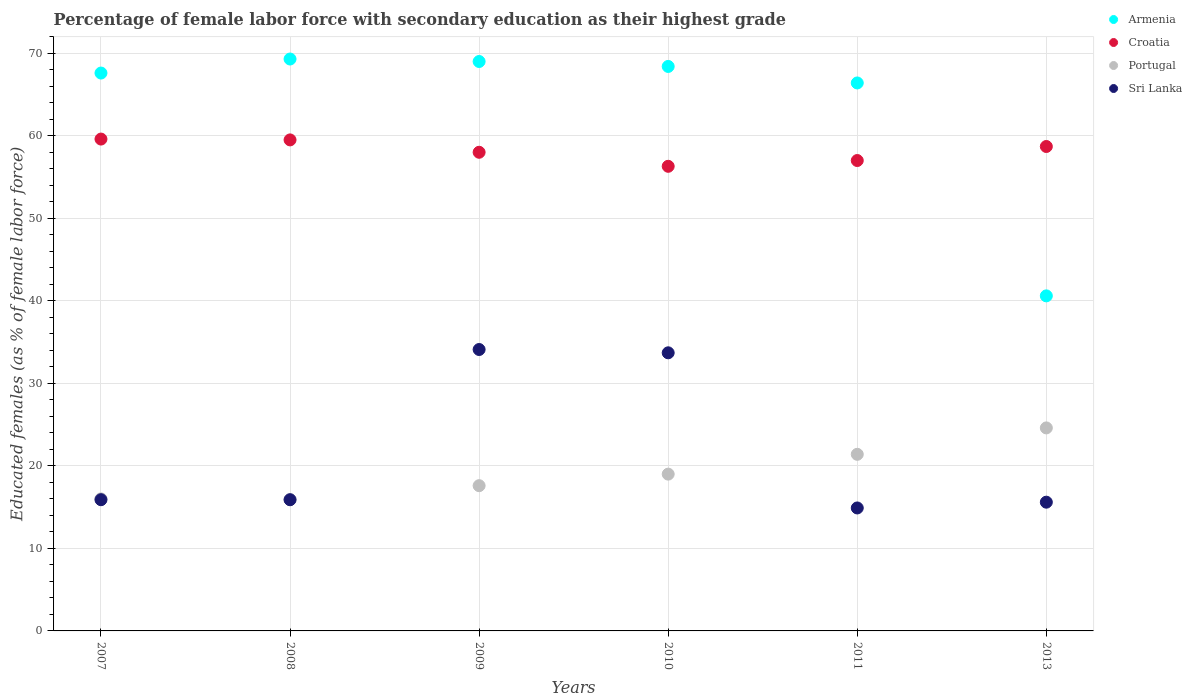How many different coloured dotlines are there?
Make the answer very short. 4. Across all years, what is the maximum percentage of female labor force with secondary education in Armenia?
Keep it short and to the point. 69.3. Across all years, what is the minimum percentage of female labor force with secondary education in Portugal?
Your answer should be compact. 15.9. In which year was the percentage of female labor force with secondary education in Croatia maximum?
Give a very brief answer. 2007. What is the total percentage of female labor force with secondary education in Sri Lanka in the graph?
Offer a very short reply. 130.1. What is the difference between the percentage of female labor force with secondary education in Sri Lanka in 2008 and that in 2013?
Keep it short and to the point. 0.3. What is the difference between the percentage of female labor force with secondary education in Armenia in 2007 and the percentage of female labor force with secondary education in Portugal in 2009?
Your answer should be very brief. 50. What is the average percentage of female labor force with secondary education in Croatia per year?
Your response must be concise. 58.18. In the year 2009, what is the difference between the percentage of female labor force with secondary education in Croatia and percentage of female labor force with secondary education in Sri Lanka?
Make the answer very short. 23.9. What is the ratio of the percentage of female labor force with secondary education in Croatia in 2009 to that in 2011?
Offer a terse response. 1.02. What is the difference between the highest and the second highest percentage of female labor force with secondary education in Sri Lanka?
Offer a terse response. 0.4. What is the difference between the highest and the lowest percentage of female labor force with secondary education in Armenia?
Provide a succinct answer. 28.7. Is it the case that in every year, the sum of the percentage of female labor force with secondary education in Sri Lanka and percentage of female labor force with secondary education in Croatia  is greater than the sum of percentage of female labor force with secondary education in Portugal and percentage of female labor force with secondary education in Armenia?
Give a very brief answer. Yes. Is it the case that in every year, the sum of the percentage of female labor force with secondary education in Croatia and percentage of female labor force with secondary education in Sri Lanka  is greater than the percentage of female labor force with secondary education in Portugal?
Ensure brevity in your answer.  Yes. Does the percentage of female labor force with secondary education in Sri Lanka monotonically increase over the years?
Provide a short and direct response. No. Is the percentage of female labor force with secondary education in Portugal strictly greater than the percentage of female labor force with secondary education in Armenia over the years?
Your answer should be compact. No. What is the difference between two consecutive major ticks on the Y-axis?
Give a very brief answer. 10. Are the values on the major ticks of Y-axis written in scientific E-notation?
Ensure brevity in your answer.  No. Does the graph contain grids?
Offer a very short reply. Yes. What is the title of the graph?
Your response must be concise. Percentage of female labor force with secondary education as their highest grade. Does "American Samoa" appear as one of the legend labels in the graph?
Provide a short and direct response. No. What is the label or title of the X-axis?
Give a very brief answer. Years. What is the label or title of the Y-axis?
Your answer should be very brief. Educated females (as % of female labor force). What is the Educated females (as % of female labor force) in Armenia in 2007?
Provide a succinct answer. 67.6. What is the Educated females (as % of female labor force) of Croatia in 2007?
Provide a succinct answer. 59.6. What is the Educated females (as % of female labor force) in Sri Lanka in 2007?
Give a very brief answer. 15.9. What is the Educated females (as % of female labor force) in Armenia in 2008?
Your response must be concise. 69.3. What is the Educated females (as % of female labor force) of Croatia in 2008?
Your response must be concise. 59.5. What is the Educated females (as % of female labor force) in Portugal in 2008?
Your answer should be compact. 15.9. What is the Educated females (as % of female labor force) of Sri Lanka in 2008?
Provide a short and direct response. 15.9. What is the Educated females (as % of female labor force) in Croatia in 2009?
Offer a terse response. 58. What is the Educated females (as % of female labor force) in Portugal in 2009?
Offer a very short reply. 17.6. What is the Educated females (as % of female labor force) in Sri Lanka in 2009?
Make the answer very short. 34.1. What is the Educated females (as % of female labor force) in Armenia in 2010?
Your answer should be very brief. 68.4. What is the Educated females (as % of female labor force) in Croatia in 2010?
Make the answer very short. 56.3. What is the Educated females (as % of female labor force) in Portugal in 2010?
Make the answer very short. 19. What is the Educated females (as % of female labor force) in Sri Lanka in 2010?
Keep it short and to the point. 33.7. What is the Educated females (as % of female labor force) in Armenia in 2011?
Your answer should be compact. 66.4. What is the Educated females (as % of female labor force) of Portugal in 2011?
Provide a short and direct response. 21.4. What is the Educated females (as % of female labor force) of Sri Lanka in 2011?
Provide a short and direct response. 14.9. What is the Educated females (as % of female labor force) in Armenia in 2013?
Provide a short and direct response. 40.6. What is the Educated females (as % of female labor force) of Croatia in 2013?
Make the answer very short. 58.7. What is the Educated females (as % of female labor force) in Portugal in 2013?
Ensure brevity in your answer.  24.6. What is the Educated females (as % of female labor force) of Sri Lanka in 2013?
Provide a succinct answer. 15.6. Across all years, what is the maximum Educated females (as % of female labor force) of Armenia?
Provide a succinct answer. 69.3. Across all years, what is the maximum Educated females (as % of female labor force) in Croatia?
Your answer should be compact. 59.6. Across all years, what is the maximum Educated females (as % of female labor force) of Portugal?
Give a very brief answer. 24.6. Across all years, what is the maximum Educated females (as % of female labor force) of Sri Lanka?
Provide a short and direct response. 34.1. Across all years, what is the minimum Educated females (as % of female labor force) in Armenia?
Provide a short and direct response. 40.6. Across all years, what is the minimum Educated females (as % of female labor force) in Croatia?
Provide a succinct answer. 56.3. Across all years, what is the minimum Educated females (as % of female labor force) of Portugal?
Provide a short and direct response. 15.9. Across all years, what is the minimum Educated females (as % of female labor force) in Sri Lanka?
Offer a very short reply. 14.9. What is the total Educated females (as % of female labor force) of Armenia in the graph?
Offer a terse response. 381.3. What is the total Educated females (as % of female labor force) of Croatia in the graph?
Make the answer very short. 349.1. What is the total Educated females (as % of female labor force) of Portugal in the graph?
Provide a succinct answer. 114.5. What is the total Educated females (as % of female labor force) of Sri Lanka in the graph?
Your answer should be compact. 130.1. What is the difference between the Educated females (as % of female labor force) in Croatia in 2007 and that in 2008?
Give a very brief answer. 0.1. What is the difference between the Educated females (as % of female labor force) of Portugal in 2007 and that in 2008?
Make the answer very short. 0.1. What is the difference between the Educated females (as % of female labor force) in Armenia in 2007 and that in 2009?
Offer a very short reply. -1.4. What is the difference between the Educated females (as % of female labor force) in Croatia in 2007 and that in 2009?
Provide a short and direct response. 1.6. What is the difference between the Educated females (as % of female labor force) of Sri Lanka in 2007 and that in 2009?
Your answer should be compact. -18.2. What is the difference between the Educated females (as % of female labor force) of Croatia in 2007 and that in 2010?
Offer a terse response. 3.3. What is the difference between the Educated females (as % of female labor force) of Sri Lanka in 2007 and that in 2010?
Give a very brief answer. -17.8. What is the difference between the Educated females (as % of female labor force) of Armenia in 2007 and that in 2011?
Offer a terse response. 1.2. What is the difference between the Educated females (as % of female labor force) of Croatia in 2007 and that in 2011?
Your answer should be very brief. 2.6. What is the difference between the Educated females (as % of female labor force) of Portugal in 2007 and that in 2011?
Provide a short and direct response. -5.4. What is the difference between the Educated females (as % of female labor force) of Sri Lanka in 2007 and that in 2011?
Offer a very short reply. 1. What is the difference between the Educated females (as % of female labor force) in Croatia in 2007 and that in 2013?
Your response must be concise. 0.9. What is the difference between the Educated females (as % of female labor force) in Sri Lanka in 2007 and that in 2013?
Give a very brief answer. 0.3. What is the difference between the Educated females (as % of female labor force) in Armenia in 2008 and that in 2009?
Give a very brief answer. 0.3. What is the difference between the Educated females (as % of female labor force) in Portugal in 2008 and that in 2009?
Keep it short and to the point. -1.7. What is the difference between the Educated females (as % of female labor force) of Sri Lanka in 2008 and that in 2009?
Your response must be concise. -18.2. What is the difference between the Educated females (as % of female labor force) of Armenia in 2008 and that in 2010?
Offer a very short reply. 0.9. What is the difference between the Educated females (as % of female labor force) of Croatia in 2008 and that in 2010?
Your answer should be compact. 3.2. What is the difference between the Educated females (as % of female labor force) in Portugal in 2008 and that in 2010?
Ensure brevity in your answer.  -3.1. What is the difference between the Educated females (as % of female labor force) in Sri Lanka in 2008 and that in 2010?
Your answer should be compact. -17.8. What is the difference between the Educated females (as % of female labor force) of Portugal in 2008 and that in 2011?
Keep it short and to the point. -5.5. What is the difference between the Educated females (as % of female labor force) of Armenia in 2008 and that in 2013?
Provide a succinct answer. 28.7. What is the difference between the Educated females (as % of female labor force) in Croatia in 2008 and that in 2013?
Make the answer very short. 0.8. What is the difference between the Educated females (as % of female labor force) in Armenia in 2009 and that in 2010?
Your response must be concise. 0.6. What is the difference between the Educated females (as % of female labor force) in Sri Lanka in 2009 and that in 2010?
Your response must be concise. 0.4. What is the difference between the Educated females (as % of female labor force) in Croatia in 2009 and that in 2011?
Your answer should be compact. 1. What is the difference between the Educated females (as % of female labor force) in Portugal in 2009 and that in 2011?
Make the answer very short. -3.8. What is the difference between the Educated females (as % of female labor force) in Armenia in 2009 and that in 2013?
Provide a short and direct response. 28.4. What is the difference between the Educated females (as % of female labor force) of Portugal in 2009 and that in 2013?
Offer a very short reply. -7. What is the difference between the Educated females (as % of female labor force) of Armenia in 2010 and that in 2011?
Provide a short and direct response. 2. What is the difference between the Educated females (as % of female labor force) of Croatia in 2010 and that in 2011?
Make the answer very short. -0.7. What is the difference between the Educated females (as % of female labor force) in Portugal in 2010 and that in 2011?
Your answer should be compact. -2.4. What is the difference between the Educated females (as % of female labor force) of Sri Lanka in 2010 and that in 2011?
Your answer should be compact. 18.8. What is the difference between the Educated females (as % of female labor force) of Armenia in 2010 and that in 2013?
Provide a short and direct response. 27.8. What is the difference between the Educated females (as % of female labor force) in Croatia in 2010 and that in 2013?
Ensure brevity in your answer.  -2.4. What is the difference between the Educated females (as % of female labor force) of Armenia in 2011 and that in 2013?
Offer a terse response. 25.8. What is the difference between the Educated females (as % of female labor force) in Armenia in 2007 and the Educated females (as % of female labor force) in Croatia in 2008?
Your response must be concise. 8.1. What is the difference between the Educated females (as % of female labor force) of Armenia in 2007 and the Educated females (as % of female labor force) of Portugal in 2008?
Offer a very short reply. 51.7. What is the difference between the Educated females (as % of female labor force) of Armenia in 2007 and the Educated females (as % of female labor force) of Sri Lanka in 2008?
Your answer should be very brief. 51.7. What is the difference between the Educated females (as % of female labor force) in Croatia in 2007 and the Educated females (as % of female labor force) in Portugal in 2008?
Your answer should be very brief. 43.7. What is the difference between the Educated females (as % of female labor force) in Croatia in 2007 and the Educated females (as % of female labor force) in Sri Lanka in 2008?
Give a very brief answer. 43.7. What is the difference between the Educated females (as % of female labor force) in Portugal in 2007 and the Educated females (as % of female labor force) in Sri Lanka in 2008?
Offer a terse response. 0.1. What is the difference between the Educated females (as % of female labor force) in Armenia in 2007 and the Educated females (as % of female labor force) in Croatia in 2009?
Your answer should be compact. 9.6. What is the difference between the Educated females (as % of female labor force) in Armenia in 2007 and the Educated females (as % of female labor force) in Portugal in 2009?
Give a very brief answer. 50. What is the difference between the Educated females (as % of female labor force) in Armenia in 2007 and the Educated females (as % of female labor force) in Sri Lanka in 2009?
Give a very brief answer. 33.5. What is the difference between the Educated females (as % of female labor force) of Croatia in 2007 and the Educated females (as % of female labor force) of Sri Lanka in 2009?
Your answer should be very brief. 25.5. What is the difference between the Educated females (as % of female labor force) of Portugal in 2007 and the Educated females (as % of female labor force) of Sri Lanka in 2009?
Offer a terse response. -18.1. What is the difference between the Educated females (as % of female labor force) in Armenia in 2007 and the Educated females (as % of female labor force) in Croatia in 2010?
Give a very brief answer. 11.3. What is the difference between the Educated females (as % of female labor force) in Armenia in 2007 and the Educated females (as % of female labor force) in Portugal in 2010?
Your response must be concise. 48.6. What is the difference between the Educated females (as % of female labor force) of Armenia in 2007 and the Educated females (as % of female labor force) of Sri Lanka in 2010?
Ensure brevity in your answer.  33.9. What is the difference between the Educated females (as % of female labor force) in Croatia in 2007 and the Educated females (as % of female labor force) in Portugal in 2010?
Make the answer very short. 40.6. What is the difference between the Educated females (as % of female labor force) in Croatia in 2007 and the Educated females (as % of female labor force) in Sri Lanka in 2010?
Keep it short and to the point. 25.9. What is the difference between the Educated females (as % of female labor force) of Portugal in 2007 and the Educated females (as % of female labor force) of Sri Lanka in 2010?
Provide a succinct answer. -17.7. What is the difference between the Educated females (as % of female labor force) of Armenia in 2007 and the Educated females (as % of female labor force) of Croatia in 2011?
Offer a terse response. 10.6. What is the difference between the Educated females (as % of female labor force) of Armenia in 2007 and the Educated females (as % of female labor force) of Portugal in 2011?
Offer a terse response. 46.2. What is the difference between the Educated females (as % of female labor force) of Armenia in 2007 and the Educated females (as % of female labor force) of Sri Lanka in 2011?
Your response must be concise. 52.7. What is the difference between the Educated females (as % of female labor force) of Croatia in 2007 and the Educated females (as % of female labor force) of Portugal in 2011?
Your answer should be compact. 38.2. What is the difference between the Educated females (as % of female labor force) of Croatia in 2007 and the Educated females (as % of female labor force) of Sri Lanka in 2011?
Offer a very short reply. 44.7. What is the difference between the Educated females (as % of female labor force) of Armenia in 2007 and the Educated females (as % of female labor force) of Croatia in 2013?
Keep it short and to the point. 8.9. What is the difference between the Educated females (as % of female labor force) in Armenia in 2007 and the Educated females (as % of female labor force) in Sri Lanka in 2013?
Provide a short and direct response. 52. What is the difference between the Educated females (as % of female labor force) of Croatia in 2007 and the Educated females (as % of female labor force) of Portugal in 2013?
Your response must be concise. 35. What is the difference between the Educated females (as % of female labor force) of Portugal in 2007 and the Educated females (as % of female labor force) of Sri Lanka in 2013?
Offer a very short reply. 0.4. What is the difference between the Educated females (as % of female labor force) in Armenia in 2008 and the Educated females (as % of female labor force) in Portugal in 2009?
Give a very brief answer. 51.7. What is the difference between the Educated females (as % of female labor force) in Armenia in 2008 and the Educated females (as % of female labor force) in Sri Lanka in 2009?
Your answer should be very brief. 35.2. What is the difference between the Educated females (as % of female labor force) in Croatia in 2008 and the Educated females (as % of female labor force) in Portugal in 2009?
Offer a very short reply. 41.9. What is the difference between the Educated females (as % of female labor force) of Croatia in 2008 and the Educated females (as % of female labor force) of Sri Lanka in 2009?
Provide a succinct answer. 25.4. What is the difference between the Educated females (as % of female labor force) in Portugal in 2008 and the Educated females (as % of female labor force) in Sri Lanka in 2009?
Provide a short and direct response. -18.2. What is the difference between the Educated females (as % of female labor force) of Armenia in 2008 and the Educated females (as % of female labor force) of Croatia in 2010?
Offer a terse response. 13. What is the difference between the Educated females (as % of female labor force) in Armenia in 2008 and the Educated females (as % of female labor force) in Portugal in 2010?
Your response must be concise. 50.3. What is the difference between the Educated females (as % of female labor force) of Armenia in 2008 and the Educated females (as % of female labor force) of Sri Lanka in 2010?
Ensure brevity in your answer.  35.6. What is the difference between the Educated females (as % of female labor force) of Croatia in 2008 and the Educated females (as % of female labor force) of Portugal in 2010?
Give a very brief answer. 40.5. What is the difference between the Educated females (as % of female labor force) of Croatia in 2008 and the Educated females (as % of female labor force) of Sri Lanka in 2010?
Provide a short and direct response. 25.8. What is the difference between the Educated females (as % of female labor force) in Portugal in 2008 and the Educated females (as % of female labor force) in Sri Lanka in 2010?
Offer a very short reply. -17.8. What is the difference between the Educated females (as % of female labor force) of Armenia in 2008 and the Educated females (as % of female labor force) of Croatia in 2011?
Offer a very short reply. 12.3. What is the difference between the Educated females (as % of female labor force) in Armenia in 2008 and the Educated females (as % of female labor force) in Portugal in 2011?
Provide a succinct answer. 47.9. What is the difference between the Educated females (as % of female labor force) in Armenia in 2008 and the Educated females (as % of female labor force) in Sri Lanka in 2011?
Your answer should be compact. 54.4. What is the difference between the Educated females (as % of female labor force) of Croatia in 2008 and the Educated females (as % of female labor force) of Portugal in 2011?
Keep it short and to the point. 38.1. What is the difference between the Educated females (as % of female labor force) of Croatia in 2008 and the Educated females (as % of female labor force) of Sri Lanka in 2011?
Your response must be concise. 44.6. What is the difference between the Educated females (as % of female labor force) in Armenia in 2008 and the Educated females (as % of female labor force) in Portugal in 2013?
Your answer should be very brief. 44.7. What is the difference between the Educated females (as % of female labor force) in Armenia in 2008 and the Educated females (as % of female labor force) in Sri Lanka in 2013?
Offer a terse response. 53.7. What is the difference between the Educated females (as % of female labor force) in Croatia in 2008 and the Educated females (as % of female labor force) in Portugal in 2013?
Make the answer very short. 34.9. What is the difference between the Educated females (as % of female labor force) in Croatia in 2008 and the Educated females (as % of female labor force) in Sri Lanka in 2013?
Give a very brief answer. 43.9. What is the difference between the Educated females (as % of female labor force) of Armenia in 2009 and the Educated females (as % of female labor force) of Croatia in 2010?
Make the answer very short. 12.7. What is the difference between the Educated females (as % of female labor force) in Armenia in 2009 and the Educated females (as % of female labor force) in Portugal in 2010?
Provide a succinct answer. 50. What is the difference between the Educated females (as % of female labor force) of Armenia in 2009 and the Educated females (as % of female labor force) of Sri Lanka in 2010?
Ensure brevity in your answer.  35.3. What is the difference between the Educated females (as % of female labor force) in Croatia in 2009 and the Educated females (as % of female labor force) in Portugal in 2010?
Your answer should be compact. 39. What is the difference between the Educated females (as % of female labor force) in Croatia in 2009 and the Educated females (as % of female labor force) in Sri Lanka in 2010?
Offer a very short reply. 24.3. What is the difference between the Educated females (as % of female labor force) of Portugal in 2009 and the Educated females (as % of female labor force) of Sri Lanka in 2010?
Make the answer very short. -16.1. What is the difference between the Educated females (as % of female labor force) of Armenia in 2009 and the Educated females (as % of female labor force) of Croatia in 2011?
Your answer should be very brief. 12. What is the difference between the Educated females (as % of female labor force) of Armenia in 2009 and the Educated females (as % of female labor force) of Portugal in 2011?
Your answer should be very brief. 47.6. What is the difference between the Educated females (as % of female labor force) in Armenia in 2009 and the Educated females (as % of female labor force) in Sri Lanka in 2011?
Keep it short and to the point. 54.1. What is the difference between the Educated females (as % of female labor force) in Croatia in 2009 and the Educated females (as % of female labor force) in Portugal in 2011?
Your answer should be compact. 36.6. What is the difference between the Educated females (as % of female labor force) in Croatia in 2009 and the Educated females (as % of female labor force) in Sri Lanka in 2011?
Your answer should be very brief. 43.1. What is the difference between the Educated females (as % of female labor force) in Armenia in 2009 and the Educated females (as % of female labor force) in Portugal in 2013?
Your answer should be compact. 44.4. What is the difference between the Educated females (as % of female labor force) of Armenia in 2009 and the Educated females (as % of female labor force) of Sri Lanka in 2013?
Give a very brief answer. 53.4. What is the difference between the Educated females (as % of female labor force) in Croatia in 2009 and the Educated females (as % of female labor force) in Portugal in 2013?
Give a very brief answer. 33.4. What is the difference between the Educated females (as % of female labor force) of Croatia in 2009 and the Educated females (as % of female labor force) of Sri Lanka in 2013?
Provide a succinct answer. 42.4. What is the difference between the Educated females (as % of female labor force) in Armenia in 2010 and the Educated females (as % of female labor force) in Croatia in 2011?
Offer a very short reply. 11.4. What is the difference between the Educated females (as % of female labor force) in Armenia in 2010 and the Educated females (as % of female labor force) in Portugal in 2011?
Offer a terse response. 47. What is the difference between the Educated females (as % of female labor force) of Armenia in 2010 and the Educated females (as % of female labor force) of Sri Lanka in 2011?
Offer a very short reply. 53.5. What is the difference between the Educated females (as % of female labor force) of Croatia in 2010 and the Educated females (as % of female labor force) of Portugal in 2011?
Make the answer very short. 34.9. What is the difference between the Educated females (as % of female labor force) in Croatia in 2010 and the Educated females (as % of female labor force) in Sri Lanka in 2011?
Ensure brevity in your answer.  41.4. What is the difference between the Educated females (as % of female labor force) in Portugal in 2010 and the Educated females (as % of female labor force) in Sri Lanka in 2011?
Give a very brief answer. 4.1. What is the difference between the Educated females (as % of female labor force) of Armenia in 2010 and the Educated females (as % of female labor force) of Portugal in 2013?
Offer a terse response. 43.8. What is the difference between the Educated females (as % of female labor force) of Armenia in 2010 and the Educated females (as % of female labor force) of Sri Lanka in 2013?
Keep it short and to the point. 52.8. What is the difference between the Educated females (as % of female labor force) of Croatia in 2010 and the Educated females (as % of female labor force) of Portugal in 2013?
Your answer should be very brief. 31.7. What is the difference between the Educated females (as % of female labor force) of Croatia in 2010 and the Educated females (as % of female labor force) of Sri Lanka in 2013?
Offer a terse response. 40.7. What is the difference between the Educated females (as % of female labor force) in Armenia in 2011 and the Educated females (as % of female labor force) in Croatia in 2013?
Make the answer very short. 7.7. What is the difference between the Educated females (as % of female labor force) in Armenia in 2011 and the Educated females (as % of female labor force) in Portugal in 2013?
Offer a terse response. 41.8. What is the difference between the Educated females (as % of female labor force) in Armenia in 2011 and the Educated females (as % of female labor force) in Sri Lanka in 2013?
Ensure brevity in your answer.  50.8. What is the difference between the Educated females (as % of female labor force) in Croatia in 2011 and the Educated females (as % of female labor force) in Portugal in 2013?
Keep it short and to the point. 32.4. What is the difference between the Educated females (as % of female labor force) of Croatia in 2011 and the Educated females (as % of female labor force) of Sri Lanka in 2013?
Your answer should be very brief. 41.4. What is the difference between the Educated females (as % of female labor force) in Portugal in 2011 and the Educated females (as % of female labor force) in Sri Lanka in 2013?
Provide a short and direct response. 5.8. What is the average Educated females (as % of female labor force) of Armenia per year?
Your answer should be very brief. 63.55. What is the average Educated females (as % of female labor force) of Croatia per year?
Your response must be concise. 58.18. What is the average Educated females (as % of female labor force) of Portugal per year?
Provide a succinct answer. 19.08. What is the average Educated females (as % of female labor force) of Sri Lanka per year?
Give a very brief answer. 21.68. In the year 2007, what is the difference between the Educated females (as % of female labor force) of Armenia and Educated females (as % of female labor force) of Portugal?
Provide a short and direct response. 51.6. In the year 2007, what is the difference between the Educated females (as % of female labor force) in Armenia and Educated females (as % of female labor force) in Sri Lanka?
Your answer should be very brief. 51.7. In the year 2007, what is the difference between the Educated females (as % of female labor force) in Croatia and Educated females (as % of female labor force) in Portugal?
Keep it short and to the point. 43.6. In the year 2007, what is the difference between the Educated females (as % of female labor force) in Croatia and Educated females (as % of female labor force) in Sri Lanka?
Provide a succinct answer. 43.7. In the year 2007, what is the difference between the Educated females (as % of female labor force) of Portugal and Educated females (as % of female labor force) of Sri Lanka?
Provide a succinct answer. 0.1. In the year 2008, what is the difference between the Educated females (as % of female labor force) of Armenia and Educated females (as % of female labor force) of Portugal?
Keep it short and to the point. 53.4. In the year 2008, what is the difference between the Educated females (as % of female labor force) in Armenia and Educated females (as % of female labor force) in Sri Lanka?
Provide a short and direct response. 53.4. In the year 2008, what is the difference between the Educated females (as % of female labor force) in Croatia and Educated females (as % of female labor force) in Portugal?
Keep it short and to the point. 43.6. In the year 2008, what is the difference between the Educated females (as % of female labor force) of Croatia and Educated females (as % of female labor force) of Sri Lanka?
Make the answer very short. 43.6. In the year 2009, what is the difference between the Educated females (as % of female labor force) in Armenia and Educated females (as % of female labor force) in Portugal?
Offer a terse response. 51.4. In the year 2009, what is the difference between the Educated females (as % of female labor force) of Armenia and Educated females (as % of female labor force) of Sri Lanka?
Offer a terse response. 34.9. In the year 2009, what is the difference between the Educated females (as % of female labor force) of Croatia and Educated females (as % of female labor force) of Portugal?
Offer a terse response. 40.4. In the year 2009, what is the difference between the Educated females (as % of female labor force) in Croatia and Educated females (as % of female labor force) in Sri Lanka?
Offer a terse response. 23.9. In the year 2009, what is the difference between the Educated females (as % of female labor force) of Portugal and Educated females (as % of female labor force) of Sri Lanka?
Your answer should be compact. -16.5. In the year 2010, what is the difference between the Educated females (as % of female labor force) of Armenia and Educated females (as % of female labor force) of Portugal?
Provide a short and direct response. 49.4. In the year 2010, what is the difference between the Educated females (as % of female labor force) of Armenia and Educated females (as % of female labor force) of Sri Lanka?
Offer a very short reply. 34.7. In the year 2010, what is the difference between the Educated females (as % of female labor force) of Croatia and Educated females (as % of female labor force) of Portugal?
Provide a short and direct response. 37.3. In the year 2010, what is the difference between the Educated females (as % of female labor force) of Croatia and Educated females (as % of female labor force) of Sri Lanka?
Your answer should be compact. 22.6. In the year 2010, what is the difference between the Educated females (as % of female labor force) in Portugal and Educated females (as % of female labor force) in Sri Lanka?
Offer a terse response. -14.7. In the year 2011, what is the difference between the Educated females (as % of female labor force) in Armenia and Educated females (as % of female labor force) in Croatia?
Your answer should be very brief. 9.4. In the year 2011, what is the difference between the Educated females (as % of female labor force) in Armenia and Educated females (as % of female labor force) in Sri Lanka?
Keep it short and to the point. 51.5. In the year 2011, what is the difference between the Educated females (as % of female labor force) in Croatia and Educated females (as % of female labor force) in Portugal?
Offer a very short reply. 35.6. In the year 2011, what is the difference between the Educated females (as % of female labor force) in Croatia and Educated females (as % of female labor force) in Sri Lanka?
Offer a terse response. 42.1. In the year 2011, what is the difference between the Educated females (as % of female labor force) in Portugal and Educated females (as % of female labor force) in Sri Lanka?
Give a very brief answer. 6.5. In the year 2013, what is the difference between the Educated females (as % of female labor force) of Armenia and Educated females (as % of female labor force) of Croatia?
Keep it short and to the point. -18.1. In the year 2013, what is the difference between the Educated females (as % of female labor force) of Armenia and Educated females (as % of female labor force) of Portugal?
Offer a terse response. 16. In the year 2013, what is the difference between the Educated females (as % of female labor force) in Armenia and Educated females (as % of female labor force) in Sri Lanka?
Offer a terse response. 25. In the year 2013, what is the difference between the Educated females (as % of female labor force) in Croatia and Educated females (as % of female labor force) in Portugal?
Offer a very short reply. 34.1. In the year 2013, what is the difference between the Educated females (as % of female labor force) of Croatia and Educated females (as % of female labor force) of Sri Lanka?
Your answer should be very brief. 43.1. What is the ratio of the Educated females (as % of female labor force) of Armenia in 2007 to that in 2008?
Give a very brief answer. 0.98. What is the ratio of the Educated females (as % of female labor force) in Croatia in 2007 to that in 2008?
Offer a very short reply. 1. What is the ratio of the Educated females (as % of female labor force) in Portugal in 2007 to that in 2008?
Provide a succinct answer. 1.01. What is the ratio of the Educated females (as % of female labor force) in Armenia in 2007 to that in 2009?
Offer a very short reply. 0.98. What is the ratio of the Educated females (as % of female labor force) in Croatia in 2007 to that in 2009?
Your answer should be compact. 1.03. What is the ratio of the Educated females (as % of female labor force) in Portugal in 2007 to that in 2009?
Offer a terse response. 0.91. What is the ratio of the Educated females (as % of female labor force) of Sri Lanka in 2007 to that in 2009?
Provide a short and direct response. 0.47. What is the ratio of the Educated females (as % of female labor force) in Armenia in 2007 to that in 2010?
Provide a short and direct response. 0.99. What is the ratio of the Educated females (as % of female labor force) in Croatia in 2007 to that in 2010?
Your response must be concise. 1.06. What is the ratio of the Educated females (as % of female labor force) of Portugal in 2007 to that in 2010?
Offer a very short reply. 0.84. What is the ratio of the Educated females (as % of female labor force) of Sri Lanka in 2007 to that in 2010?
Ensure brevity in your answer.  0.47. What is the ratio of the Educated females (as % of female labor force) of Armenia in 2007 to that in 2011?
Keep it short and to the point. 1.02. What is the ratio of the Educated females (as % of female labor force) in Croatia in 2007 to that in 2011?
Provide a succinct answer. 1.05. What is the ratio of the Educated females (as % of female labor force) in Portugal in 2007 to that in 2011?
Offer a terse response. 0.75. What is the ratio of the Educated females (as % of female labor force) of Sri Lanka in 2007 to that in 2011?
Ensure brevity in your answer.  1.07. What is the ratio of the Educated females (as % of female labor force) in Armenia in 2007 to that in 2013?
Make the answer very short. 1.67. What is the ratio of the Educated females (as % of female labor force) of Croatia in 2007 to that in 2013?
Ensure brevity in your answer.  1.02. What is the ratio of the Educated females (as % of female labor force) of Portugal in 2007 to that in 2013?
Your response must be concise. 0.65. What is the ratio of the Educated females (as % of female labor force) in Sri Lanka in 2007 to that in 2013?
Your answer should be compact. 1.02. What is the ratio of the Educated females (as % of female labor force) in Armenia in 2008 to that in 2009?
Offer a very short reply. 1. What is the ratio of the Educated females (as % of female labor force) in Croatia in 2008 to that in 2009?
Ensure brevity in your answer.  1.03. What is the ratio of the Educated females (as % of female labor force) of Portugal in 2008 to that in 2009?
Your answer should be compact. 0.9. What is the ratio of the Educated females (as % of female labor force) of Sri Lanka in 2008 to that in 2009?
Give a very brief answer. 0.47. What is the ratio of the Educated females (as % of female labor force) of Armenia in 2008 to that in 2010?
Provide a short and direct response. 1.01. What is the ratio of the Educated females (as % of female labor force) of Croatia in 2008 to that in 2010?
Offer a very short reply. 1.06. What is the ratio of the Educated females (as % of female labor force) in Portugal in 2008 to that in 2010?
Keep it short and to the point. 0.84. What is the ratio of the Educated females (as % of female labor force) of Sri Lanka in 2008 to that in 2010?
Offer a very short reply. 0.47. What is the ratio of the Educated females (as % of female labor force) of Armenia in 2008 to that in 2011?
Give a very brief answer. 1.04. What is the ratio of the Educated females (as % of female labor force) of Croatia in 2008 to that in 2011?
Your response must be concise. 1.04. What is the ratio of the Educated females (as % of female labor force) in Portugal in 2008 to that in 2011?
Your response must be concise. 0.74. What is the ratio of the Educated females (as % of female labor force) of Sri Lanka in 2008 to that in 2011?
Make the answer very short. 1.07. What is the ratio of the Educated females (as % of female labor force) in Armenia in 2008 to that in 2013?
Your answer should be very brief. 1.71. What is the ratio of the Educated females (as % of female labor force) in Croatia in 2008 to that in 2013?
Your response must be concise. 1.01. What is the ratio of the Educated females (as % of female labor force) in Portugal in 2008 to that in 2013?
Keep it short and to the point. 0.65. What is the ratio of the Educated females (as % of female labor force) of Sri Lanka in 2008 to that in 2013?
Your answer should be compact. 1.02. What is the ratio of the Educated females (as % of female labor force) of Armenia in 2009 to that in 2010?
Provide a succinct answer. 1.01. What is the ratio of the Educated females (as % of female labor force) in Croatia in 2009 to that in 2010?
Ensure brevity in your answer.  1.03. What is the ratio of the Educated females (as % of female labor force) in Portugal in 2009 to that in 2010?
Give a very brief answer. 0.93. What is the ratio of the Educated females (as % of female labor force) of Sri Lanka in 2009 to that in 2010?
Your answer should be compact. 1.01. What is the ratio of the Educated females (as % of female labor force) of Armenia in 2009 to that in 2011?
Offer a terse response. 1.04. What is the ratio of the Educated females (as % of female labor force) of Croatia in 2009 to that in 2011?
Provide a succinct answer. 1.02. What is the ratio of the Educated females (as % of female labor force) of Portugal in 2009 to that in 2011?
Ensure brevity in your answer.  0.82. What is the ratio of the Educated females (as % of female labor force) of Sri Lanka in 2009 to that in 2011?
Offer a very short reply. 2.29. What is the ratio of the Educated females (as % of female labor force) in Armenia in 2009 to that in 2013?
Keep it short and to the point. 1.7. What is the ratio of the Educated females (as % of female labor force) of Croatia in 2009 to that in 2013?
Provide a succinct answer. 0.99. What is the ratio of the Educated females (as % of female labor force) in Portugal in 2009 to that in 2013?
Your answer should be very brief. 0.72. What is the ratio of the Educated females (as % of female labor force) in Sri Lanka in 2009 to that in 2013?
Your response must be concise. 2.19. What is the ratio of the Educated females (as % of female labor force) of Armenia in 2010 to that in 2011?
Keep it short and to the point. 1.03. What is the ratio of the Educated females (as % of female labor force) of Portugal in 2010 to that in 2011?
Your answer should be compact. 0.89. What is the ratio of the Educated females (as % of female labor force) of Sri Lanka in 2010 to that in 2011?
Keep it short and to the point. 2.26. What is the ratio of the Educated females (as % of female labor force) of Armenia in 2010 to that in 2013?
Your response must be concise. 1.68. What is the ratio of the Educated females (as % of female labor force) of Croatia in 2010 to that in 2013?
Give a very brief answer. 0.96. What is the ratio of the Educated females (as % of female labor force) of Portugal in 2010 to that in 2013?
Your answer should be very brief. 0.77. What is the ratio of the Educated females (as % of female labor force) of Sri Lanka in 2010 to that in 2013?
Offer a very short reply. 2.16. What is the ratio of the Educated females (as % of female labor force) in Armenia in 2011 to that in 2013?
Give a very brief answer. 1.64. What is the ratio of the Educated females (as % of female labor force) of Portugal in 2011 to that in 2013?
Provide a short and direct response. 0.87. What is the ratio of the Educated females (as % of female labor force) of Sri Lanka in 2011 to that in 2013?
Ensure brevity in your answer.  0.96. What is the difference between the highest and the second highest Educated females (as % of female labor force) of Portugal?
Keep it short and to the point. 3.2. What is the difference between the highest and the lowest Educated females (as % of female labor force) of Armenia?
Keep it short and to the point. 28.7. What is the difference between the highest and the lowest Educated females (as % of female labor force) in Croatia?
Your response must be concise. 3.3. What is the difference between the highest and the lowest Educated females (as % of female labor force) of Portugal?
Make the answer very short. 8.7. 